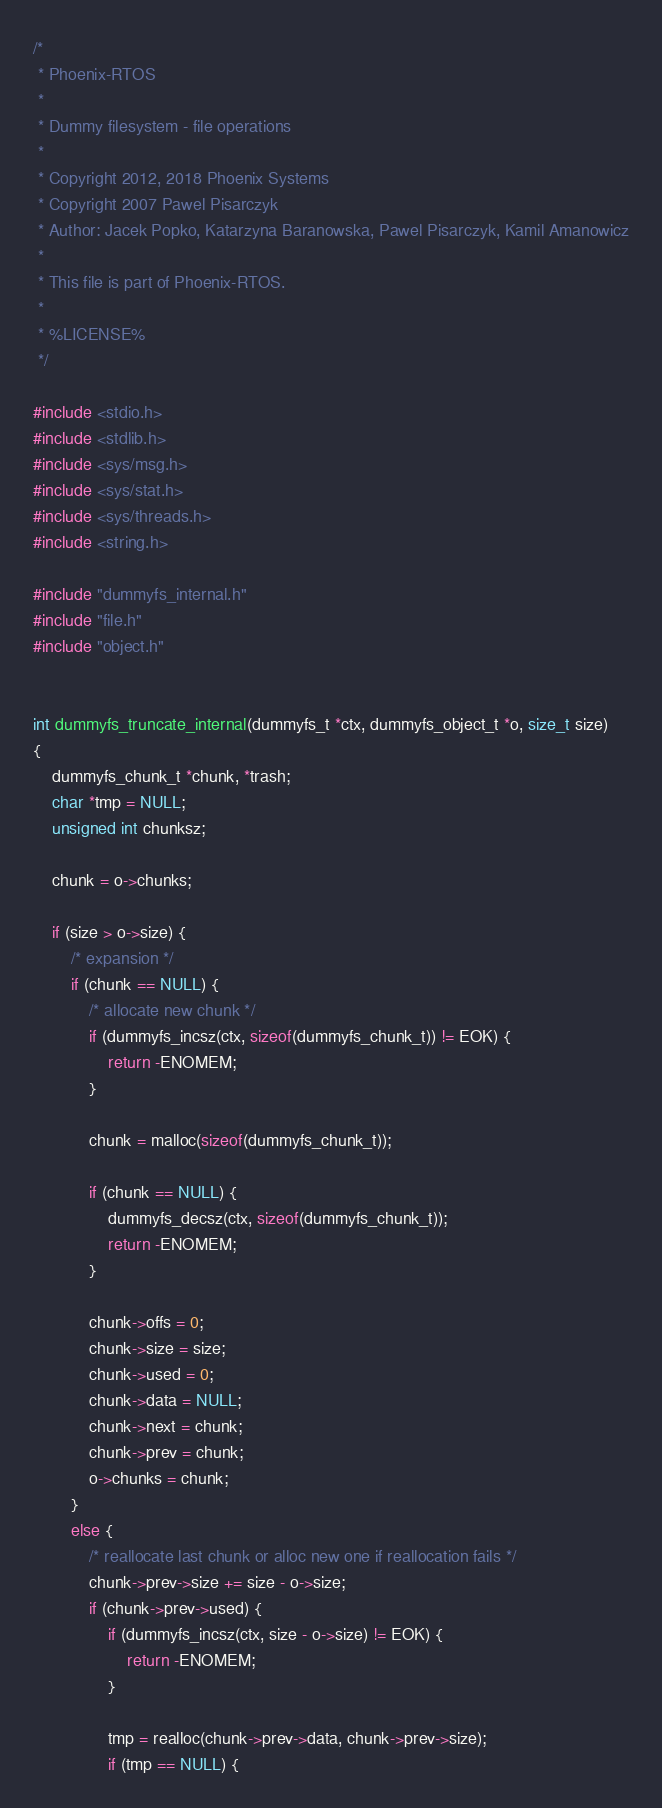Convert code to text. <code><loc_0><loc_0><loc_500><loc_500><_C_>/*
 * Phoenix-RTOS
 *
 * Dummy filesystem - file operations
 *
 * Copyright 2012, 2018 Phoenix Systems
 * Copyright 2007 Pawel Pisarczyk
 * Author: Jacek Popko, Katarzyna Baranowska, Pawel Pisarczyk, Kamil Amanowicz
 *
 * This file is part of Phoenix-RTOS.
 *
 * %LICENSE%
 */

#include <stdio.h>
#include <stdlib.h>
#include <sys/msg.h>
#include <sys/stat.h>
#include <sys/threads.h>
#include <string.h>

#include "dummyfs_internal.h"
#include "file.h"
#include "object.h"


int dummyfs_truncate_internal(dummyfs_t *ctx, dummyfs_object_t *o, size_t size)
{
	dummyfs_chunk_t *chunk, *trash;
	char *tmp = NULL;
	unsigned int chunksz;

	chunk = o->chunks;

	if (size > o->size) {
		/* expansion */
		if (chunk == NULL) {
			/* allocate new chunk */
			if (dummyfs_incsz(ctx, sizeof(dummyfs_chunk_t)) != EOK) {
				return -ENOMEM;
			}

			chunk = malloc(sizeof(dummyfs_chunk_t));

			if (chunk == NULL) {
				dummyfs_decsz(ctx, sizeof(dummyfs_chunk_t));
				return -ENOMEM;
			}

			chunk->offs = 0;
			chunk->size = size;
			chunk->used = 0;
			chunk->data = NULL;
			chunk->next = chunk;
			chunk->prev = chunk;
			o->chunks = chunk;
		}
		else {
			/* reallocate last chunk or alloc new one if reallocation fails */
			chunk->prev->size += size - o->size;
			if (chunk->prev->used) {
				if (dummyfs_incsz(ctx, size - o->size) != EOK) {
					return -ENOMEM;
				}

				tmp = realloc(chunk->prev->data, chunk->prev->size);
				if (tmp == NULL) {</code> 